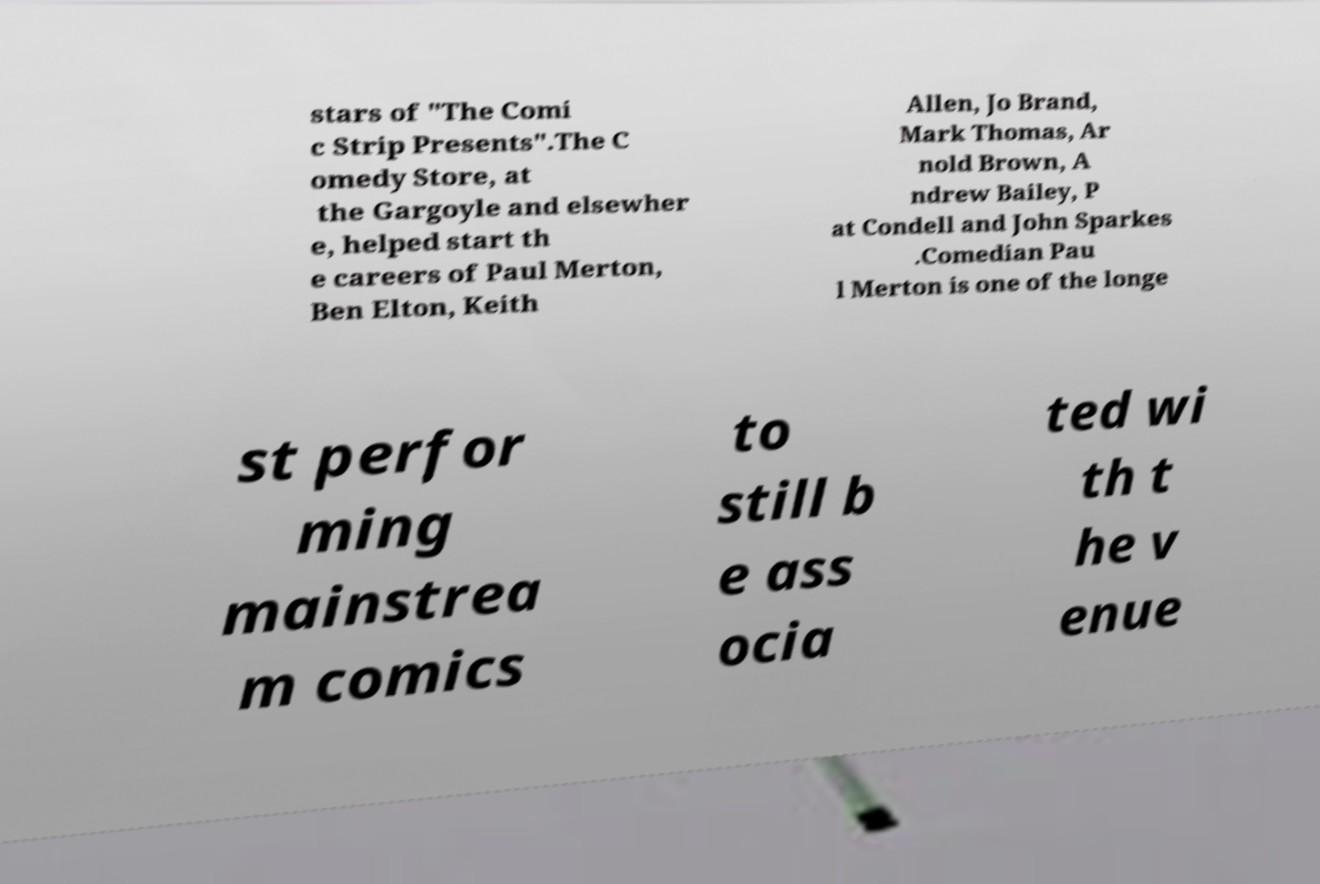Please read and relay the text visible in this image. What does it say? stars of "The Comi c Strip Presents".The C omedy Store, at the Gargoyle and elsewher e, helped start th e careers of Paul Merton, Ben Elton, Keith Allen, Jo Brand, Mark Thomas, Ar nold Brown, A ndrew Bailey, P at Condell and John Sparkes .Comedian Pau l Merton is one of the longe st perfor ming mainstrea m comics to still b e ass ocia ted wi th t he v enue 